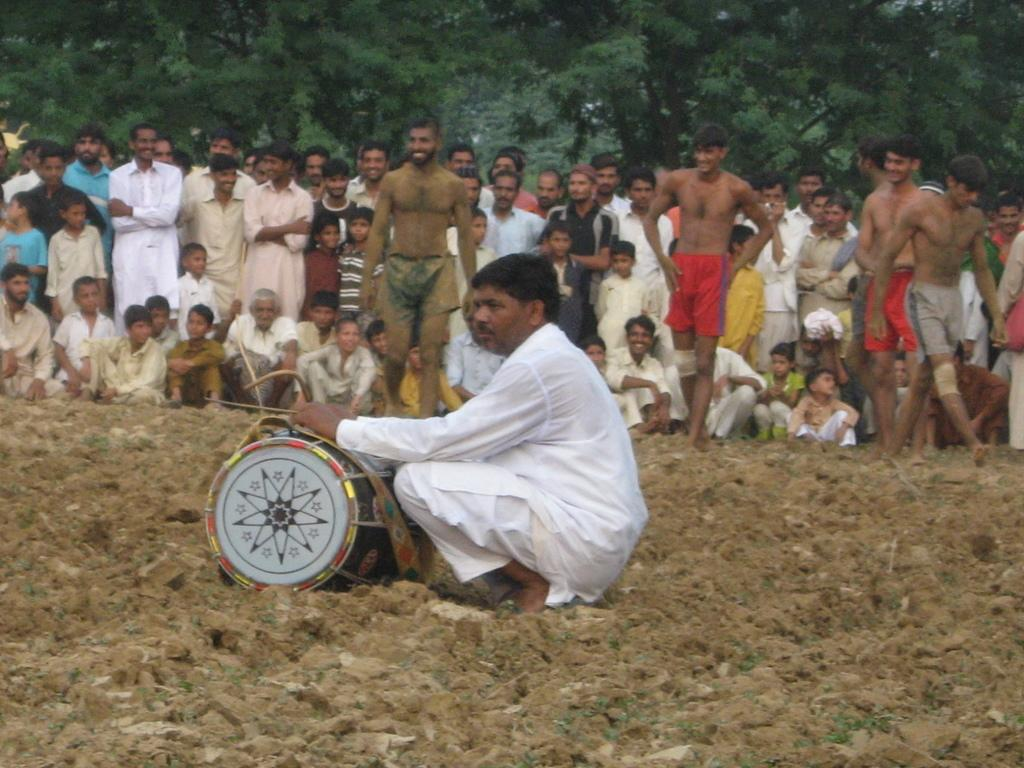Who or what can be seen in the image? There are people in the image. What object related to music is present in the image? There is a musical drum in the image. What type of natural environment is visible in the image? There are trees in the image. What is one person doing in the image? One person is holding objects. Can you tell me how many rivers are flowing through the image? There are no rivers present in the image; it features people, a musical drum, trees, and a person holding objects. 